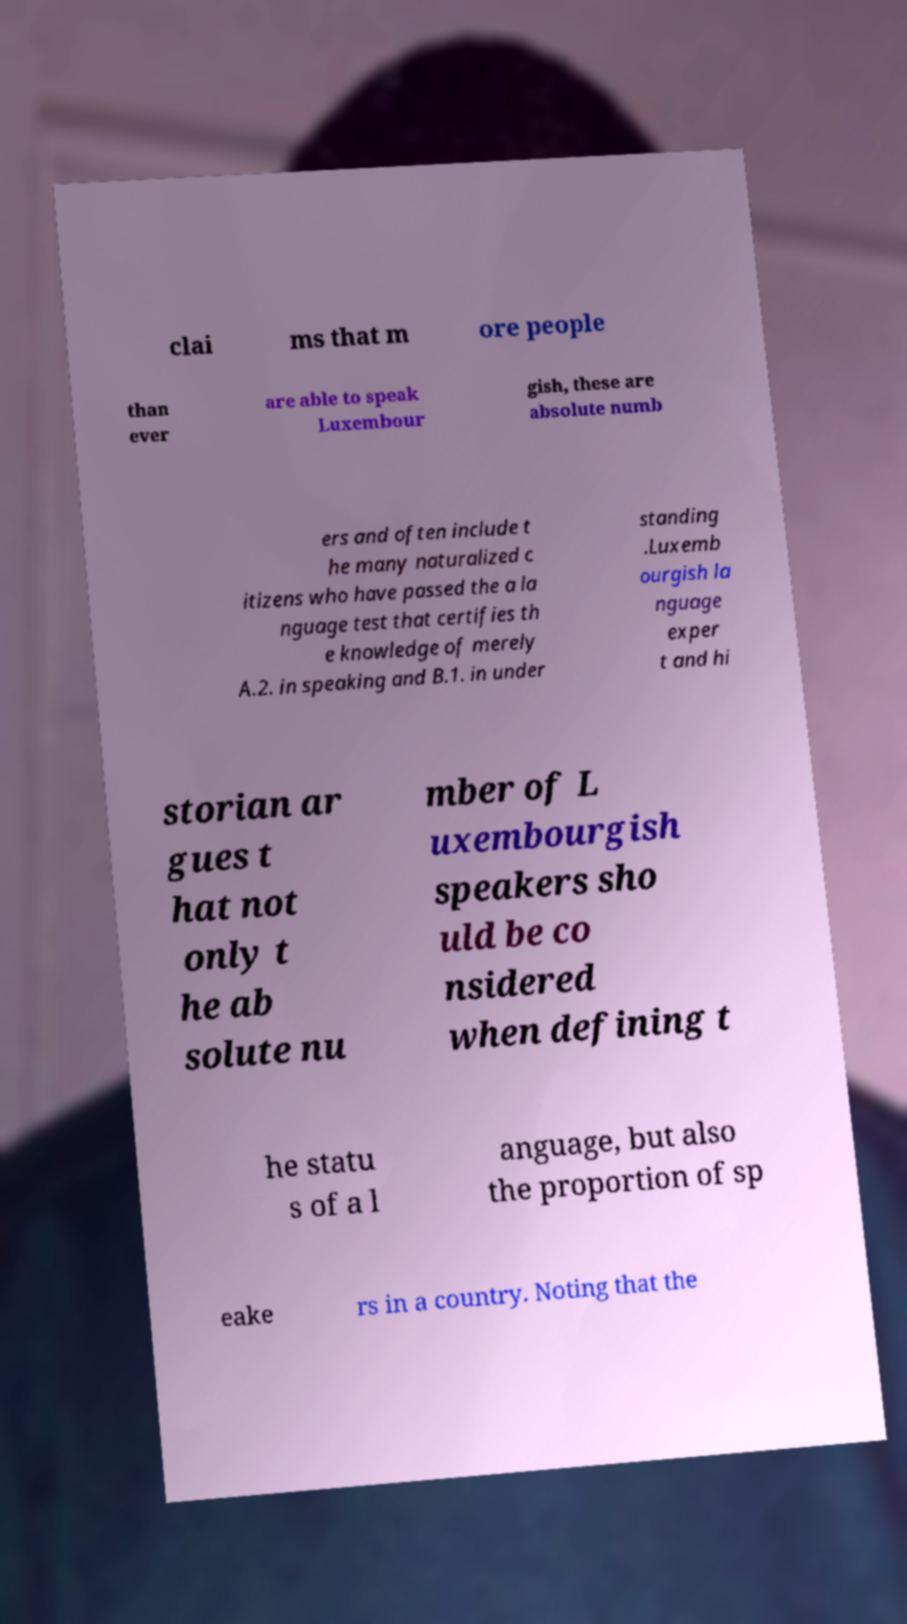Could you extract and type out the text from this image? clai ms that m ore people than ever are able to speak Luxembour gish, these are absolute numb ers and often include t he many naturalized c itizens who have passed the a la nguage test that certifies th e knowledge of merely A.2. in speaking and B.1. in under standing .Luxemb ourgish la nguage exper t and hi storian ar gues t hat not only t he ab solute nu mber of L uxembourgish speakers sho uld be co nsidered when defining t he statu s of a l anguage, but also the proportion of sp eake rs in a country. Noting that the 